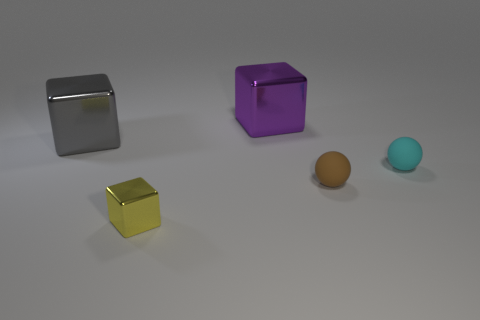Are there more small cyan spheres that are in front of the cyan thing than small spheres that are behind the brown rubber ball?
Your response must be concise. No. What is the size of the cyan matte sphere?
Your answer should be compact. Small. Does the metal object that is to the right of the tiny cube have the same color as the small shiny block?
Your response must be concise. No. Are there any other things that are the same shape as the purple object?
Offer a terse response. Yes. Is there a tiny block behind the tiny ball that is behind the brown thing?
Provide a succinct answer. No. Is the number of big things in front of the small cyan rubber thing less than the number of cubes that are behind the gray object?
Keep it short and to the point. Yes. There is a cube in front of the ball to the right of the tiny ball in front of the tiny cyan ball; what size is it?
Your answer should be compact. Small. There is a thing that is in front of the brown sphere; is it the same size as the small brown rubber sphere?
Keep it short and to the point. Yes. What number of other things are there of the same material as the small cyan sphere
Keep it short and to the point. 1. Is the number of brown matte things greater than the number of small things?
Give a very brief answer. No. 